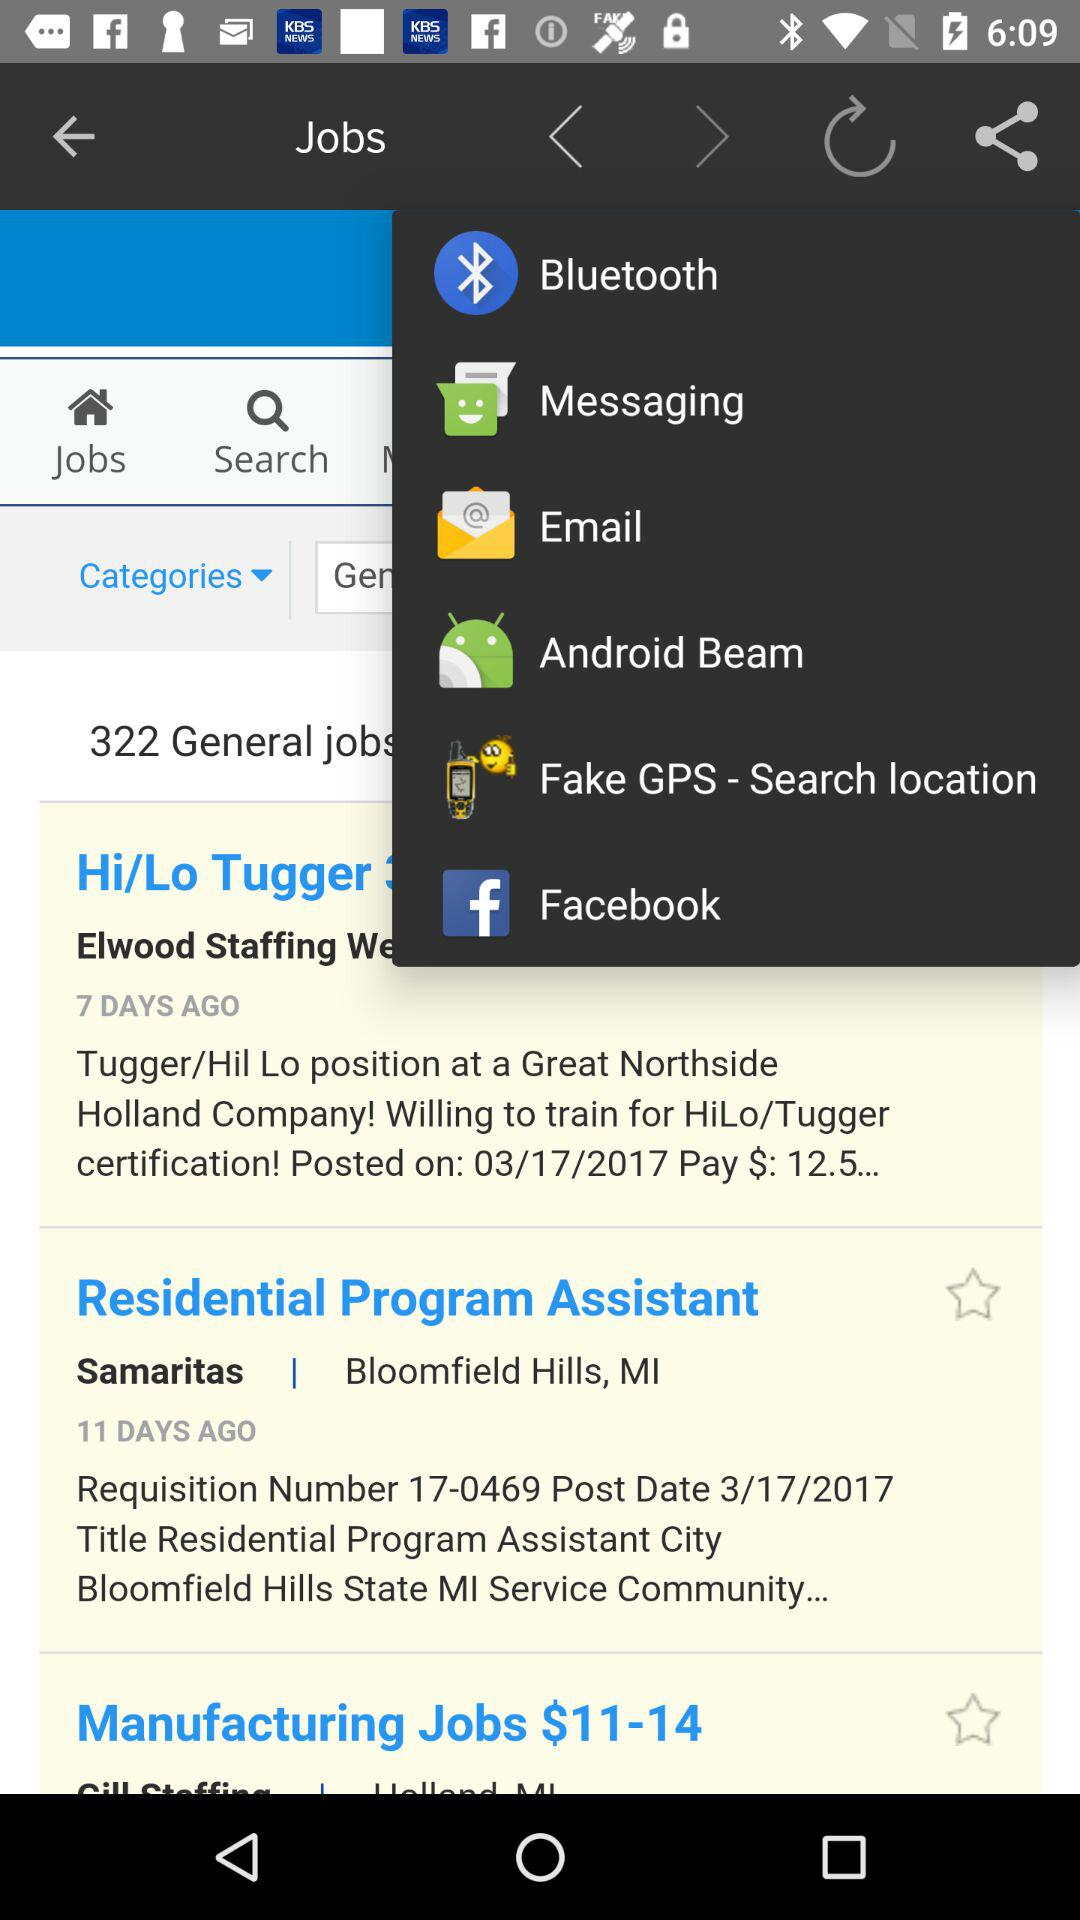What is the requisition number for the "Residential Program Assistant" job? The requisition number is 17-0469. 